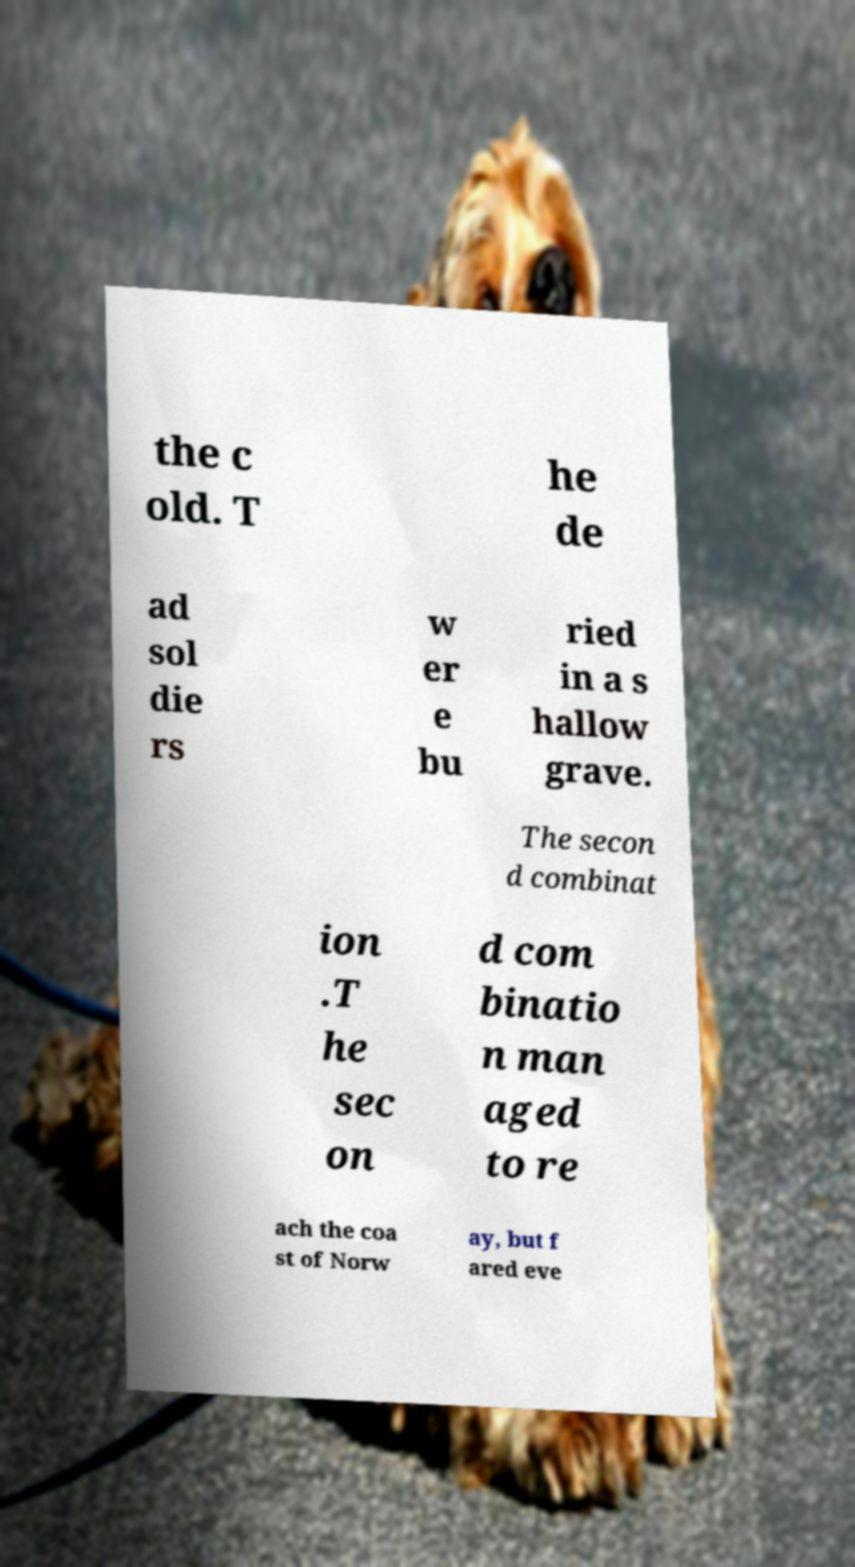Please read and relay the text visible in this image. What does it say? the c old. T he de ad sol die rs w er e bu ried in a s hallow grave. The secon d combinat ion .T he sec on d com binatio n man aged to re ach the coa st of Norw ay, but f ared eve 